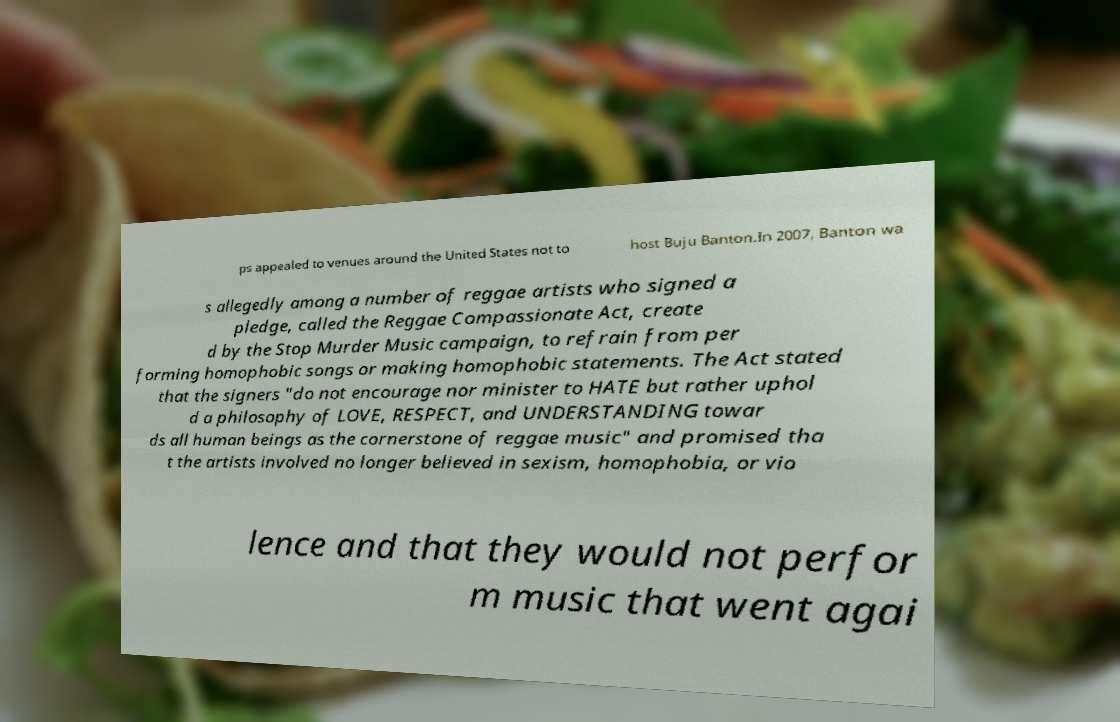Can you read and provide the text displayed in the image?This photo seems to have some interesting text. Can you extract and type it out for me? ps appealed to venues around the United States not to host Buju Banton.In 2007, Banton wa s allegedly among a number of reggae artists who signed a pledge, called the Reggae Compassionate Act, create d by the Stop Murder Music campaign, to refrain from per forming homophobic songs or making homophobic statements. The Act stated that the signers "do not encourage nor minister to HATE but rather uphol d a philosophy of LOVE, RESPECT, and UNDERSTANDING towar ds all human beings as the cornerstone of reggae music" and promised tha t the artists involved no longer believed in sexism, homophobia, or vio lence and that they would not perfor m music that went agai 